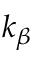<formula> <loc_0><loc_0><loc_500><loc_500>k _ { \beta }</formula> 